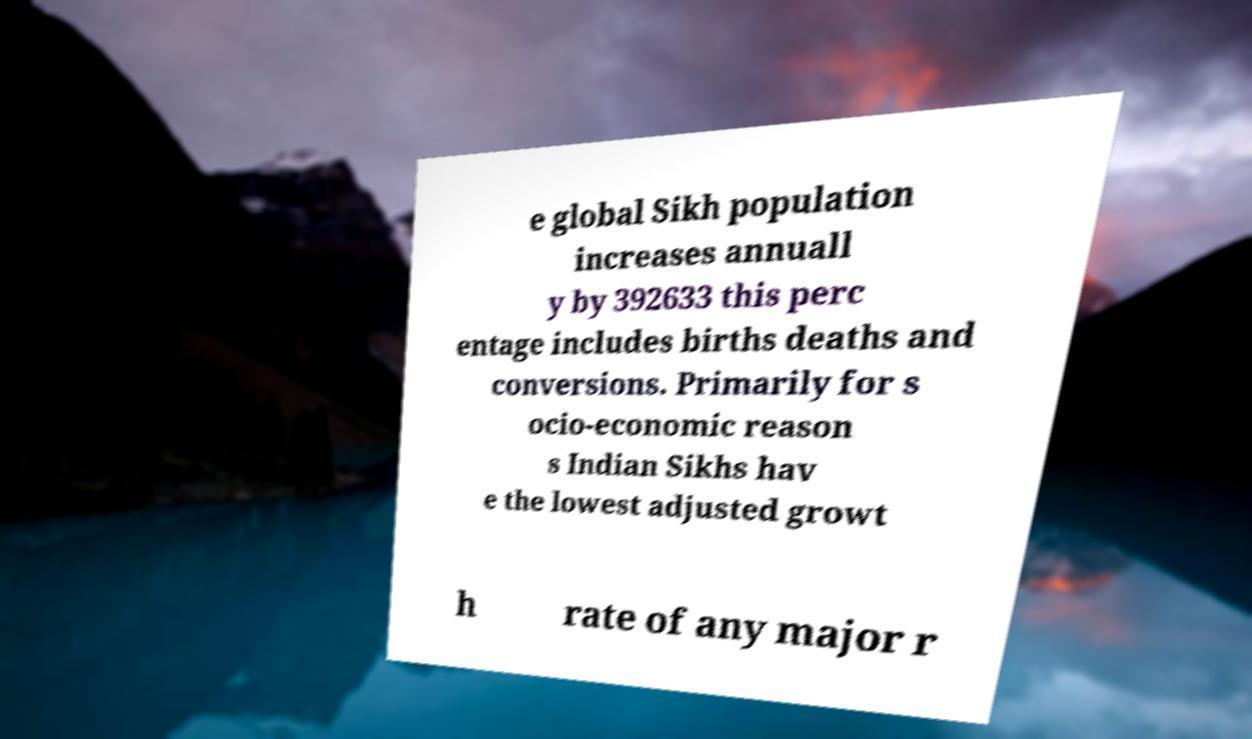What messages or text are displayed in this image? I need them in a readable, typed format. e global Sikh population increases annuall y by 392633 this perc entage includes births deaths and conversions. Primarily for s ocio-economic reason s Indian Sikhs hav e the lowest adjusted growt h rate of any major r 